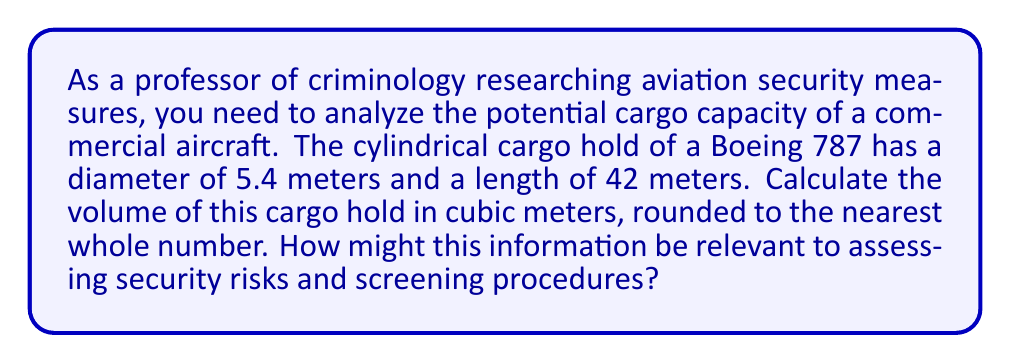Provide a solution to this math problem. To calculate the volume of a cylindrical cargo hold, we need to use the formula for the volume of a cylinder:

$$V = \pi r^2 h$$

Where:
$V$ = volume
$r$ = radius of the base
$h$ = height (length) of the cylinder

Given:
- Diameter = 5.4 meters
- Length = 42 meters

Step 1: Calculate the radius
The radius is half the diameter:
$r = 5.4 \div 2 = 2.7$ meters

Step 2: Apply the formula
$$\begin{align*}
V &= \pi r^2 h \\
&= \pi \times (2.7\text{ m})^2 \times 42\text{ m} \\
&= \pi \times 7.29\text{ m}^2 \times 42\text{ m} \\
&= 960.884... \text{ m}^3
\end{align*}$$

Step 3: Round to the nearest whole number
$960.884...\text{ m}^3 \approx 961\text{ m}^3$

This information is relevant to assessing security risks and screening procedures because:
1. It helps determine the maximum amount of cargo that can be loaded, which affects the thoroughness and time required for screening.
2. Understanding the cargo volume aids in developing efficient scanning and inspection methods.
3. It allows for the estimation of potential threats based on the size and quantity of items that could be concealed.
4. This knowledge can inform decisions on staffing and equipment needs for cargo screening.
Answer: The volume of the cylindrical cargo hold is approximately 961 cubic meters. 